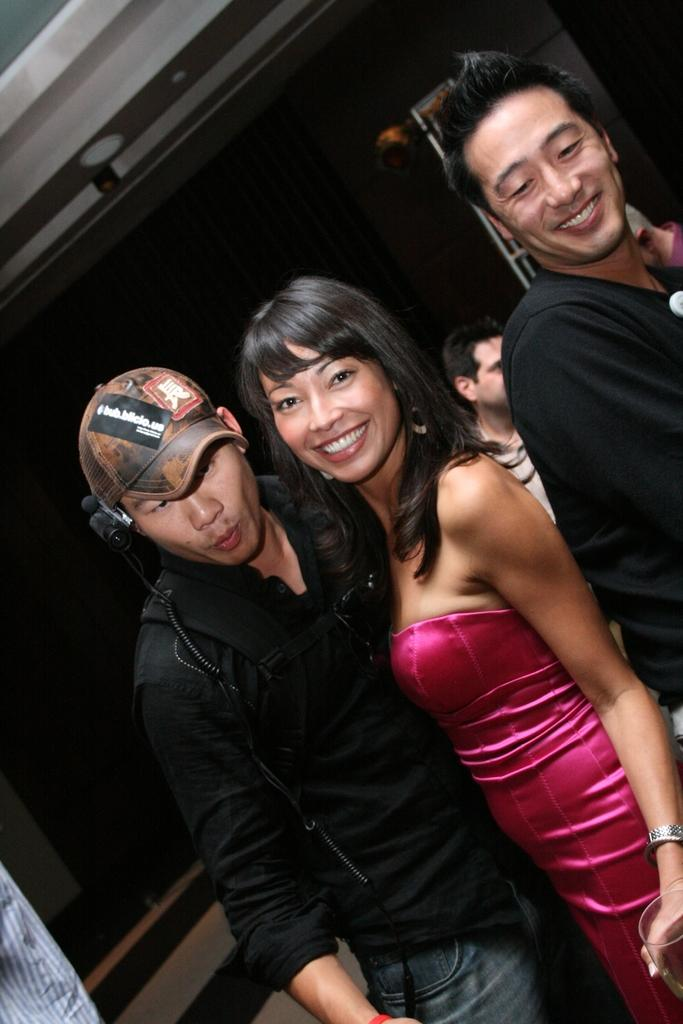How many persons are wearing black dresses in the image? There are two persons wearing black dresses in the image. What are these two persons doing? These two persons are standing. Can you describe the positioning of the woman in the image? There is a woman standing between the two persons wearing black dresses. Are there any other people visible in the image? Yes, there is another person in the background of the image. What type of kitty can be seen playing with the support in the image? There is no kitty or support present in the image. 